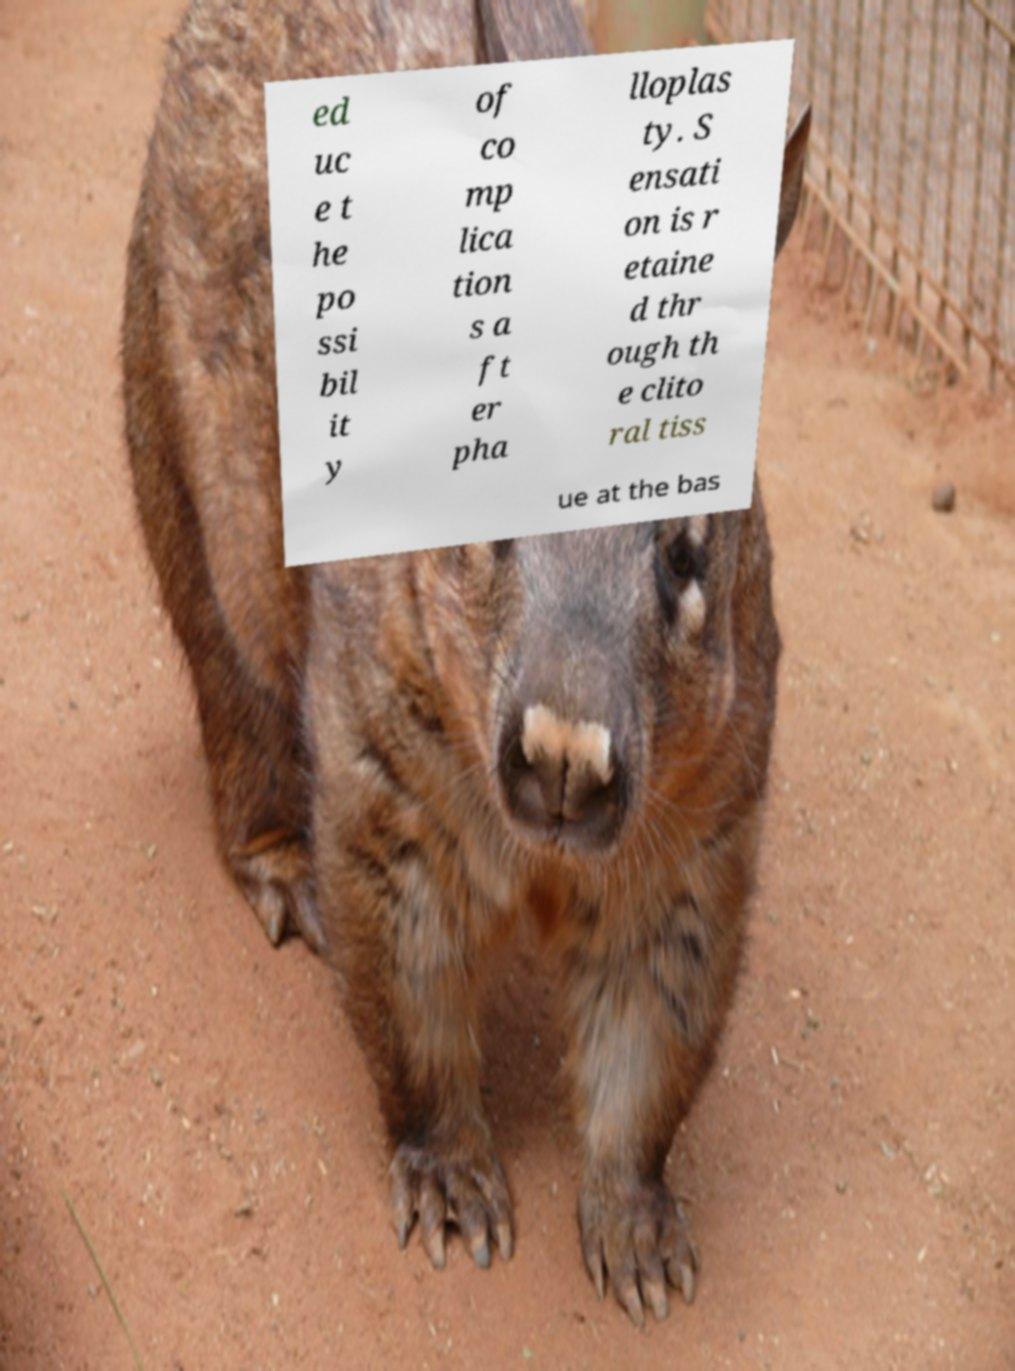Could you extract and type out the text from this image? ed uc e t he po ssi bil it y of co mp lica tion s a ft er pha lloplas ty. S ensati on is r etaine d thr ough th e clito ral tiss ue at the bas 